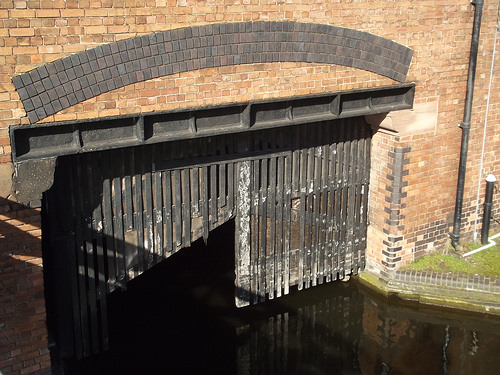<image>
Is there a fence under the water? No. The fence is not positioned under the water. The vertical relationship between these objects is different. 